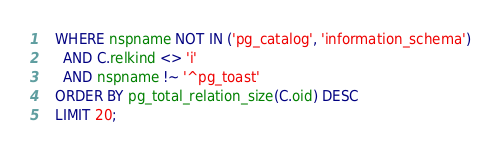<code> <loc_0><loc_0><loc_500><loc_500><_SQL_>  WHERE nspname NOT IN ('pg_catalog', 'information_schema')
    AND C.relkind <> 'i'
    AND nspname !~ '^pg_toast'
  ORDER BY pg_total_relation_size(C.oid) DESC
  LIMIT 20;
</code> 